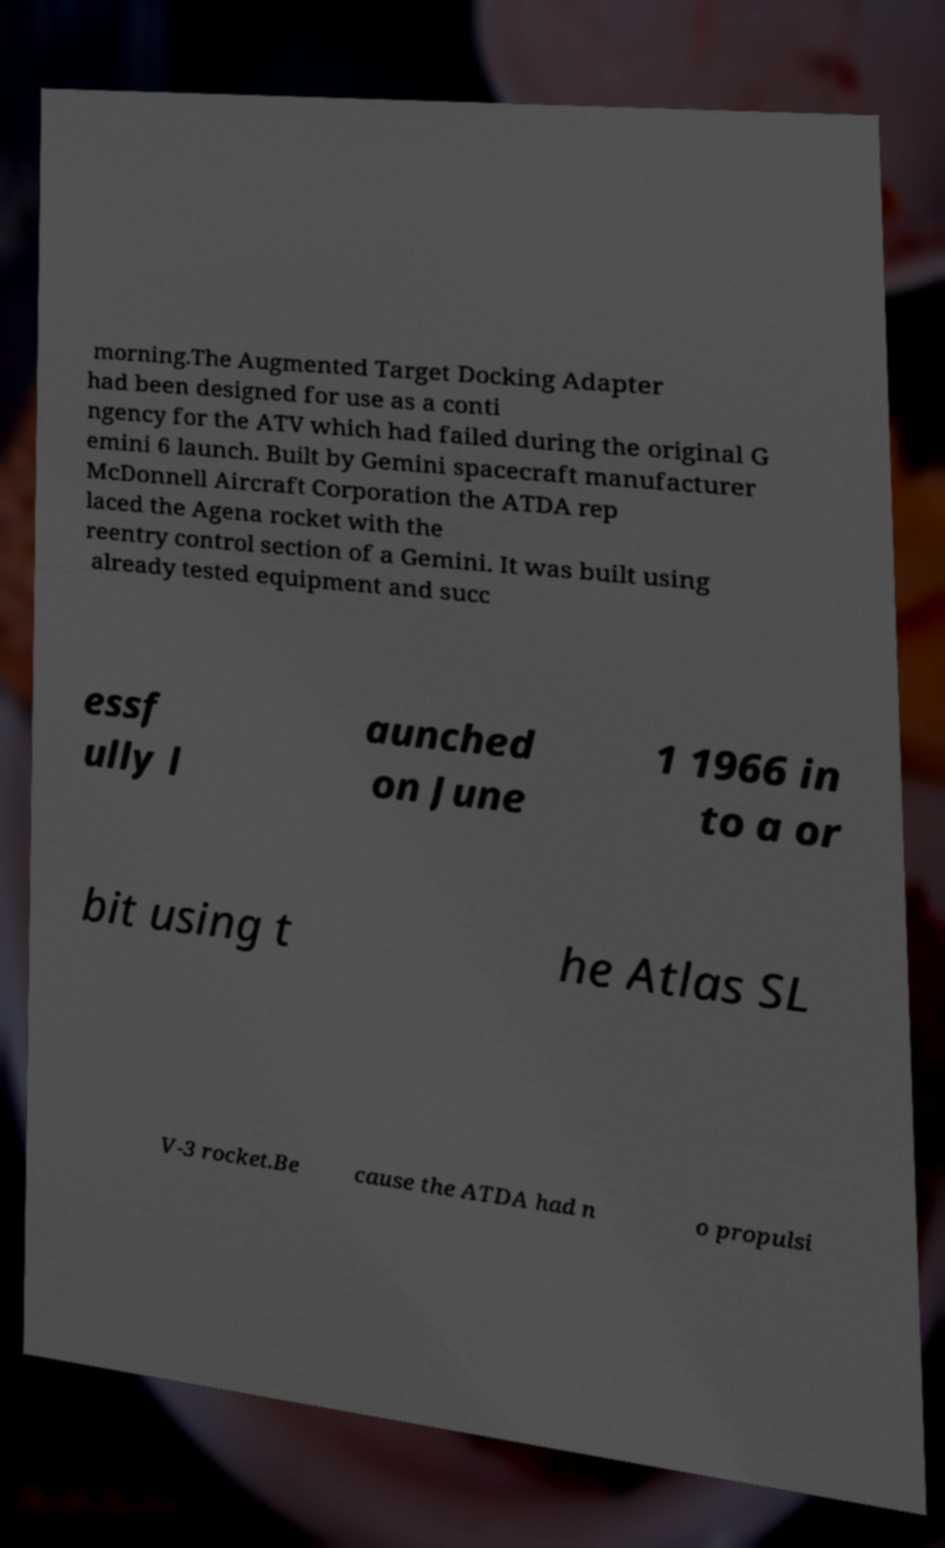Please identify and transcribe the text found in this image. morning.The Augmented Target Docking Adapter had been designed for use as a conti ngency for the ATV which had failed during the original G emini 6 launch. Built by Gemini spacecraft manufacturer McDonnell Aircraft Corporation the ATDA rep laced the Agena rocket with the reentry control section of a Gemini. It was built using already tested equipment and succ essf ully l aunched on June 1 1966 in to a or bit using t he Atlas SL V-3 rocket.Be cause the ATDA had n o propulsi 